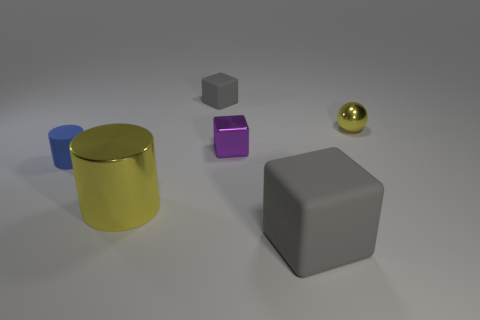Add 2 tiny blue objects. How many objects exist? 8 Subtract all spheres. How many objects are left? 5 Subtract all yellow shiny things. Subtract all blue cylinders. How many objects are left? 3 Add 1 small blue cylinders. How many small blue cylinders are left? 2 Add 5 large purple rubber cubes. How many large purple rubber cubes exist? 5 Subtract 1 blue cylinders. How many objects are left? 5 